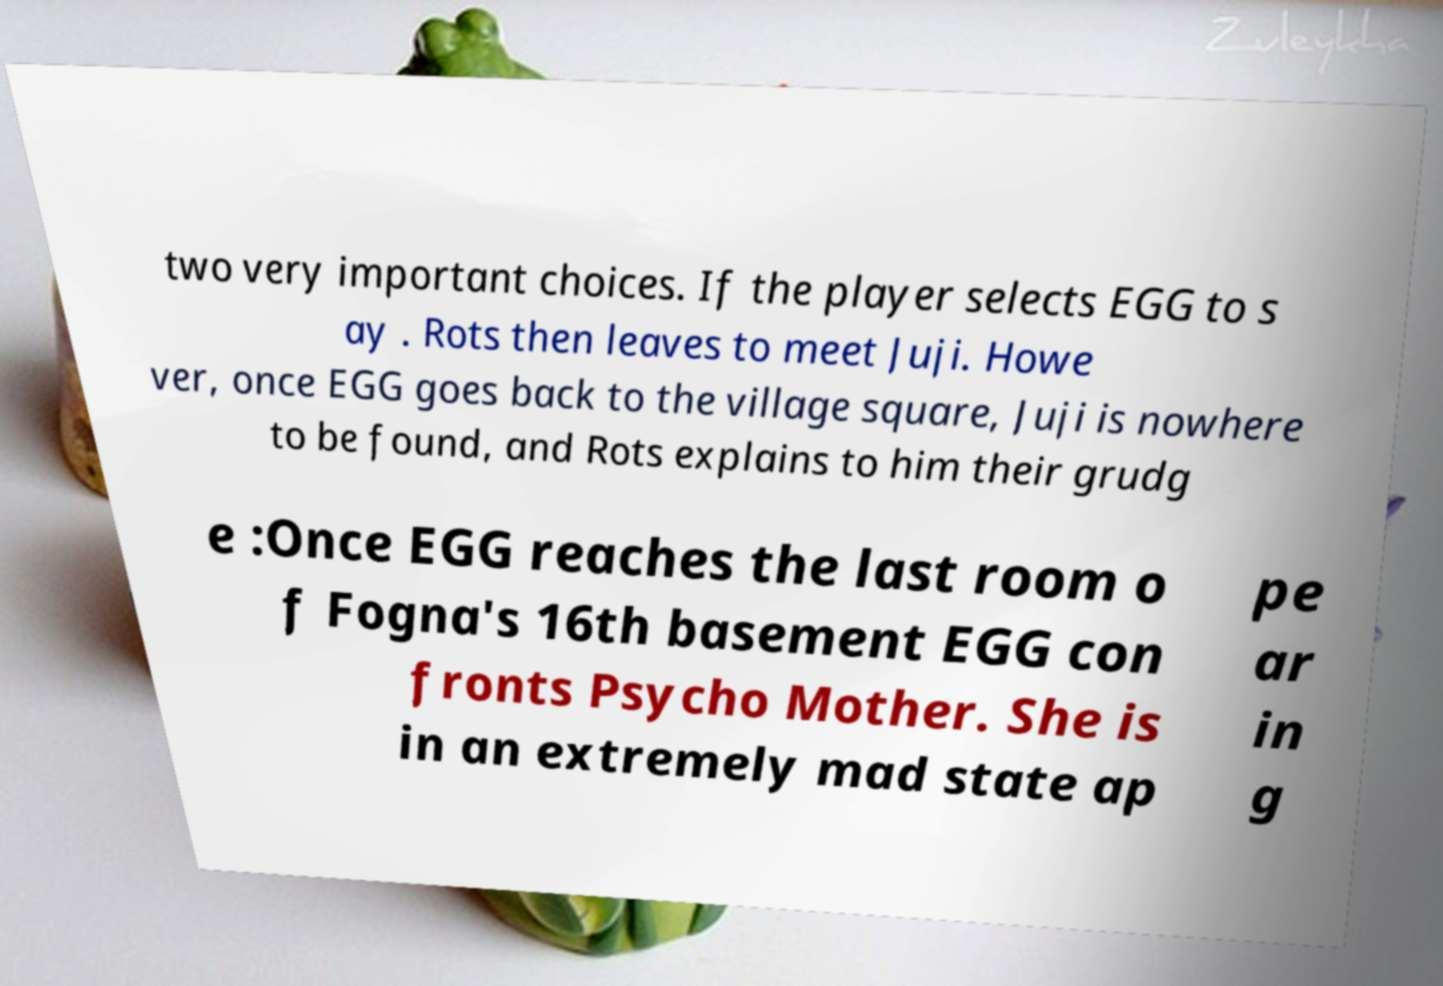Can you read and provide the text displayed in the image?This photo seems to have some interesting text. Can you extract and type it out for me? two very important choices. If the player selects EGG to s ay . Rots then leaves to meet Juji. Howe ver, once EGG goes back to the village square, Juji is nowhere to be found, and Rots explains to him their grudg e :Once EGG reaches the last room o f Fogna's 16th basement EGG con fronts Psycho Mother. She is in an extremely mad state ap pe ar in g 